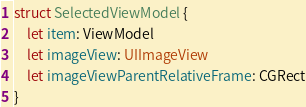<code> <loc_0><loc_0><loc_500><loc_500><_Swift_>
struct SelectedViewModel {
    let item: ViewModel
    let imageView: UIImageView
    let imageViewParentRelativeFrame: CGRect
}
</code> 